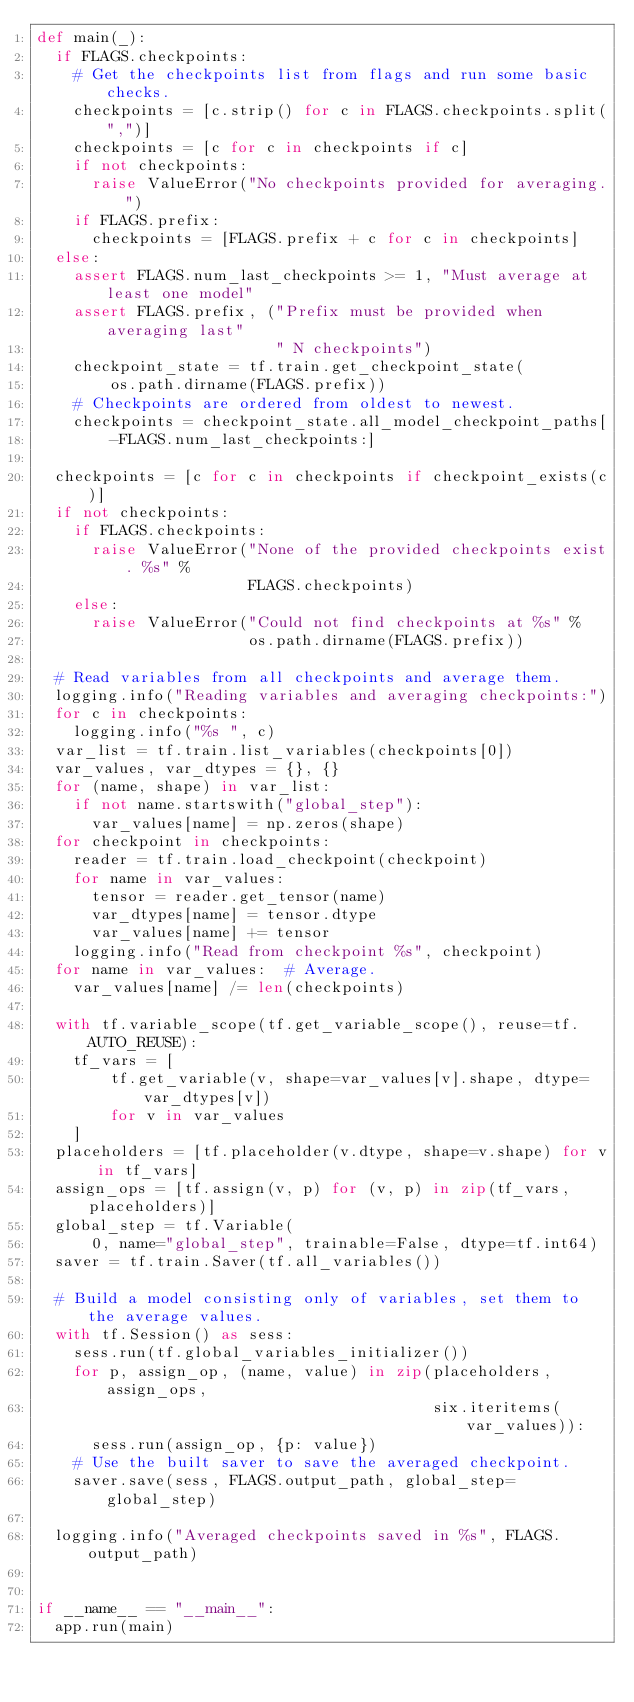<code> <loc_0><loc_0><loc_500><loc_500><_Python_>def main(_):
  if FLAGS.checkpoints:
    # Get the checkpoints list from flags and run some basic checks.
    checkpoints = [c.strip() for c in FLAGS.checkpoints.split(",")]
    checkpoints = [c for c in checkpoints if c]
    if not checkpoints:
      raise ValueError("No checkpoints provided for averaging.")
    if FLAGS.prefix:
      checkpoints = [FLAGS.prefix + c for c in checkpoints]
  else:
    assert FLAGS.num_last_checkpoints >= 1, "Must average at least one model"
    assert FLAGS.prefix, ("Prefix must be provided when averaging last"
                          " N checkpoints")
    checkpoint_state = tf.train.get_checkpoint_state(
        os.path.dirname(FLAGS.prefix))
    # Checkpoints are ordered from oldest to newest.
    checkpoints = checkpoint_state.all_model_checkpoint_paths[
        -FLAGS.num_last_checkpoints:]

  checkpoints = [c for c in checkpoints if checkpoint_exists(c)]
  if not checkpoints:
    if FLAGS.checkpoints:
      raise ValueError("None of the provided checkpoints exist. %s" %
                       FLAGS.checkpoints)
    else:
      raise ValueError("Could not find checkpoints at %s" %
                       os.path.dirname(FLAGS.prefix))

  # Read variables from all checkpoints and average them.
  logging.info("Reading variables and averaging checkpoints:")
  for c in checkpoints:
    logging.info("%s ", c)
  var_list = tf.train.list_variables(checkpoints[0])
  var_values, var_dtypes = {}, {}
  for (name, shape) in var_list:
    if not name.startswith("global_step"):
      var_values[name] = np.zeros(shape)
  for checkpoint in checkpoints:
    reader = tf.train.load_checkpoint(checkpoint)
    for name in var_values:
      tensor = reader.get_tensor(name)
      var_dtypes[name] = tensor.dtype
      var_values[name] += tensor
    logging.info("Read from checkpoint %s", checkpoint)
  for name in var_values:  # Average.
    var_values[name] /= len(checkpoints)

  with tf.variable_scope(tf.get_variable_scope(), reuse=tf.AUTO_REUSE):
    tf_vars = [
        tf.get_variable(v, shape=var_values[v].shape, dtype=var_dtypes[v])
        for v in var_values
    ]
  placeholders = [tf.placeholder(v.dtype, shape=v.shape) for v in tf_vars]
  assign_ops = [tf.assign(v, p) for (v, p) in zip(tf_vars, placeholders)]
  global_step = tf.Variable(
      0, name="global_step", trainable=False, dtype=tf.int64)
  saver = tf.train.Saver(tf.all_variables())

  # Build a model consisting only of variables, set them to the average values.
  with tf.Session() as sess:
    sess.run(tf.global_variables_initializer())
    for p, assign_op, (name, value) in zip(placeholders, assign_ops,
                                           six.iteritems(var_values)):
      sess.run(assign_op, {p: value})
    # Use the built saver to save the averaged checkpoint.
    saver.save(sess, FLAGS.output_path, global_step=global_step)

  logging.info("Averaged checkpoints saved in %s", FLAGS.output_path)


if __name__ == "__main__":
  app.run(main)
</code> 